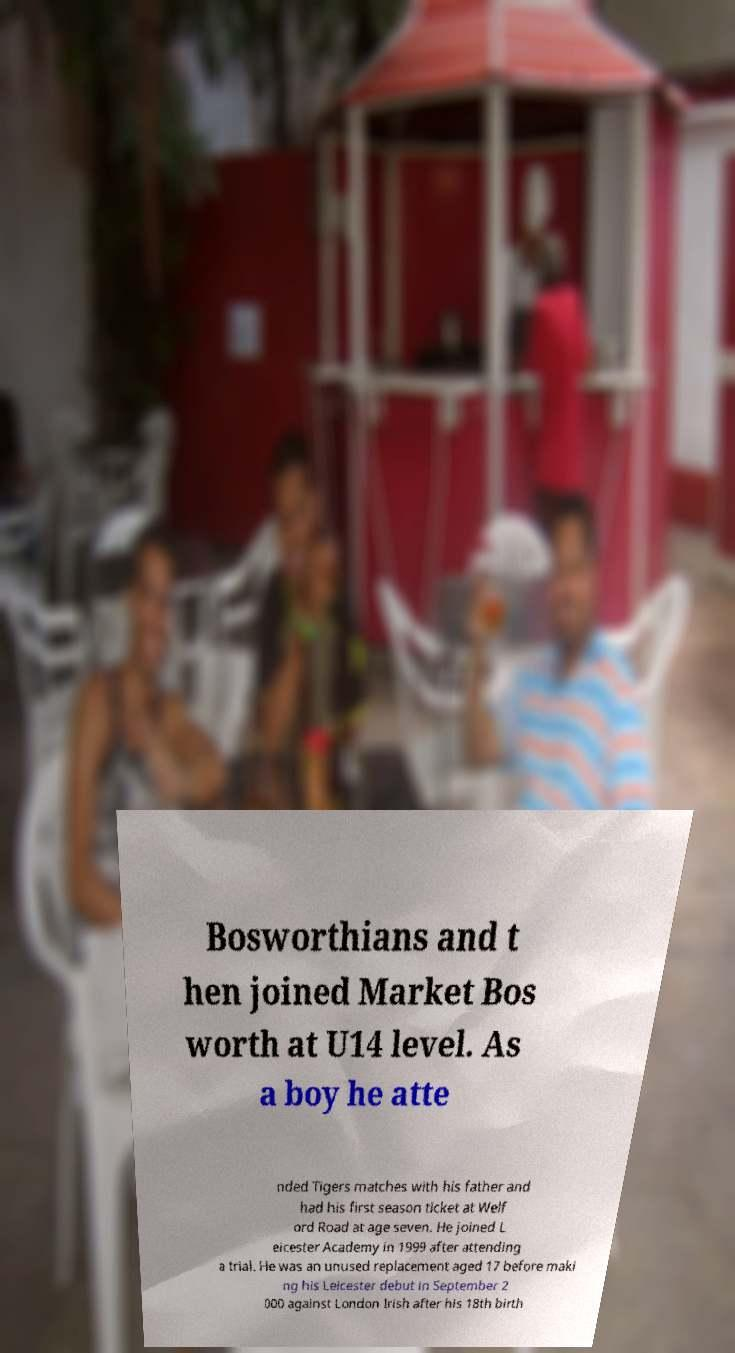Please identify and transcribe the text found in this image. Bosworthians and t hen joined Market Bos worth at U14 level. As a boy he atte nded Tigers matches with his father and had his first season ticket at Welf ord Road at age seven. He joined L eicester Academy in 1999 after attending a trial. He was an unused replacement aged 17 before maki ng his Leicester debut in September 2 000 against London Irish after his 18th birth 